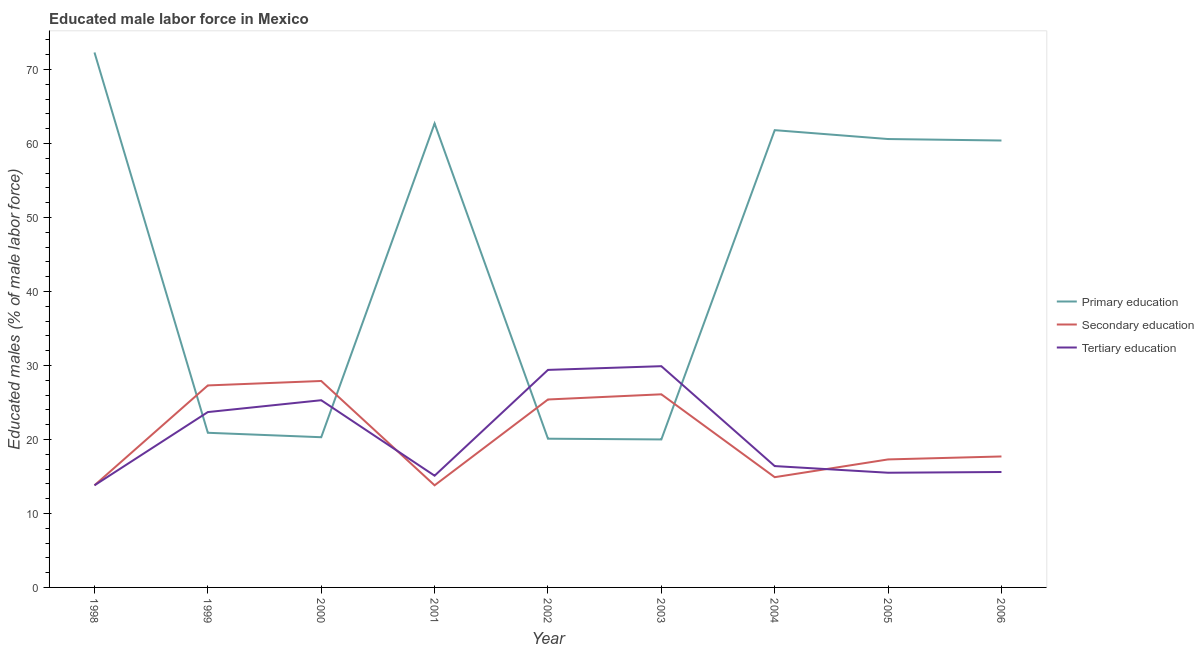How many different coloured lines are there?
Provide a short and direct response. 3. Does the line corresponding to percentage of male labor force who received secondary education intersect with the line corresponding to percentage of male labor force who received primary education?
Make the answer very short. Yes. What is the percentage of male labor force who received primary education in 1999?
Your answer should be compact. 20.9. Across all years, what is the maximum percentage of male labor force who received primary education?
Your answer should be very brief. 72.3. In which year was the percentage of male labor force who received tertiary education maximum?
Offer a very short reply. 2003. In which year was the percentage of male labor force who received primary education minimum?
Give a very brief answer. 2003. What is the total percentage of male labor force who received primary education in the graph?
Ensure brevity in your answer.  399.1. What is the difference between the percentage of male labor force who received secondary education in 1998 and that in 2004?
Your answer should be compact. -1.1. What is the difference between the percentage of male labor force who received primary education in 2004 and the percentage of male labor force who received secondary education in 2005?
Keep it short and to the point. 44.5. What is the average percentage of male labor force who received primary education per year?
Your response must be concise. 44.34. In the year 2003, what is the difference between the percentage of male labor force who received tertiary education and percentage of male labor force who received primary education?
Your answer should be very brief. 9.9. In how many years, is the percentage of male labor force who received secondary education greater than 18 %?
Keep it short and to the point. 4. What is the ratio of the percentage of male labor force who received secondary education in 2005 to that in 2006?
Give a very brief answer. 0.98. Is the percentage of male labor force who received tertiary education in 2003 less than that in 2004?
Offer a very short reply. No. Is the difference between the percentage of male labor force who received primary education in 1998 and 2006 greater than the difference between the percentage of male labor force who received secondary education in 1998 and 2006?
Your response must be concise. Yes. What is the difference between the highest and the lowest percentage of male labor force who received secondary education?
Ensure brevity in your answer.  14.1. Is the sum of the percentage of male labor force who received tertiary education in 2000 and 2004 greater than the maximum percentage of male labor force who received primary education across all years?
Make the answer very short. No. Is the percentage of male labor force who received secondary education strictly less than the percentage of male labor force who received primary education over the years?
Provide a short and direct response. No. How many lines are there?
Your response must be concise. 3. What is the difference between two consecutive major ticks on the Y-axis?
Keep it short and to the point. 10. Does the graph contain any zero values?
Offer a very short reply. No. Does the graph contain grids?
Offer a terse response. No. How many legend labels are there?
Ensure brevity in your answer.  3. What is the title of the graph?
Provide a succinct answer. Educated male labor force in Mexico. Does "Social Insurance" appear as one of the legend labels in the graph?
Your answer should be compact. No. What is the label or title of the Y-axis?
Offer a very short reply. Educated males (% of male labor force). What is the Educated males (% of male labor force) of Primary education in 1998?
Ensure brevity in your answer.  72.3. What is the Educated males (% of male labor force) of Secondary education in 1998?
Your answer should be very brief. 13.8. What is the Educated males (% of male labor force) of Tertiary education in 1998?
Your response must be concise. 13.8. What is the Educated males (% of male labor force) of Primary education in 1999?
Your answer should be very brief. 20.9. What is the Educated males (% of male labor force) in Secondary education in 1999?
Make the answer very short. 27.3. What is the Educated males (% of male labor force) of Tertiary education in 1999?
Give a very brief answer. 23.7. What is the Educated males (% of male labor force) of Primary education in 2000?
Your answer should be compact. 20.3. What is the Educated males (% of male labor force) of Secondary education in 2000?
Keep it short and to the point. 27.9. What is the Educated males (% of male labor force) in Tertiary education in 2000?
Keep it short and to the point. 25.3. What is the Educated males (% of male labor force) in Primary education in 2001?
Make the answer very short. 62.7. What is the Educated males (% of male labor force) in Secondary education in 2001?
Keep it short and to the point. 13.8. What is the Educated males (% of male labor force) of Tertiary education in 2001?
Make the answer very short. 15.1. What is the Educated males (% of male labor force) in Primary education in 2002?
Your answer should be compact. 20.1. What is the Educated males (% of male labor force) of Secondary education in 2002?
Make the answer very short. 25.4. What is the Educated males (% of male labor force) of Tertiary education in 2002?
Provide a short and direct response. 29.4. What is the Educated males (% of male labor force) of Primary education in 2003?
Provide a succinct answer. 20. What is the Educated males (% of male labor force) in Secondary education in 2003?
Give a very brief answer. 26.1. What is the Educated males (% of male labor force) in Tertiary education in 2003?
Offer a terse response. 29.9. What is the Educated males (% of male labor force) in Primary education in 2004?
Offer a terse response. 61.8. What is the Educated males (% of male labor force) in Secondary education in 2004?
Your answer should be compact. 14.9. What is the Educated males (% of male labor force) in Tertiary education in 2004?
Give a very brief answer. 16.4. What is the Educated males (% of male labor force) in Primary education in 2005?
Keep it short and to the point. 60.6. What is the Educated males (% of male labor force) of Secondary education in 2005?
Ensure brevity in your answer.  17.3. What is the Educated males (% of male labor force) of Primary education in 2006?
Offer a very short reply. 60.4. What is the Educated males (% of male labor force) of Secondary education in 2006?
Offer a terse response. 17.7. What is the Educated males (% of male labor force) in Tertiary education in 2006?
Offer a terse response. 15.6. Across all years, what is the maximum Educated males (% of male labor force) of Primary education?
Provide a short and direct response. 72.3. Across all years, what is the maximum Educated males (% of male labor force) in Secondary education?
Make the answer very short. 27.9. Across all years, what is the maximum Educated males (% of male labor force) in Tertiary education?
Offer a terse response. 29.9. Across all years, what is the minimum Educated males (% of male labor force) in Primary education?
Provide a succinct answer. 20. Across all years, what is the minimum Educated males (% of male labor force) in Secondary education?
Make the answer very short. 13.8. Across all years, what is the minimum Educated males (% of male labor force) of Tertiary education?
Keep it short and to the point. 13.8. What is the total Educated males (% of male labor force) in Primary education in the graph?
Your answer should be compact. 399.1. What is the total Educated males (% of male labor force) in Secondary education in the graph?
Provide a short and direct response. 184.2. What is the total Educated males (% of male labor force) of Tertiary education in the graph?
Your answer should be very brief. 184.7. What is the difference between the Educated males (% of male labor force) of Primary education in 1998 and that in 1999?
Offer a very short reply. 51.4. What is the difference between the Educated males (% of male labor force) in Secondary education in 1998 and that in 1999?
Provide a succinct answer. -13.5. What is the difference between the Educated males (% of male labor force) in Tertiary education in 1998 and that in 1999?
Keep it short and to the point. -9.9. What is the difference between the Educated males (% of male labor force) of Secondary education in 1998 and that in 2000?
Your response must be concise. -14.1. What is the difference between the Educated males (% of male labor force) in Tertiary education in 1998 and that in 2000?
Your answer should be compact. -11.5. What is the difference between the Educated males (% of male labor force) in Primary education in 1998 and that in 2002?
Provide a succinct answer. 52.2. What is the difference between the Educated males (% of male labor force) in Tertiary education in 1998 and that in 2002?
Your response must be concise. -15.6. What is the difference between the Educated males (% of male labor force) in Primary education in 1998 and that in 2003?
Offer a very short reply. 52.3. What is the difference between the Educated males (% of male labor force) of Tertiary education in 1998 and that in 2003?
Offer a very short reply. -16.1. What is the difference between the Educated males (% of male labor force) in Primary education in 1998 and that in 2004?
Make the answer very short. 10.5. What is the difference between the Educated males (% of male labor force) in Tertiary education in 1998 and that in 2004?
Your response must be concise. -2.6. What is the difference between the Educated males (% of male labor force) in Secondary education in 1998 and that in 2005?
Your answer should be very brief. -3.5. What is the difference between the Educated males (% of male labor force) in Tertiary education in 1998 and that in 2005?
Offer a very short reply. -1.7. What is the difference between the Educated males (% of male labor force) of Tertiary education in 1999 and that in 2000?
Your answer should be compact. -1.6. What is the difference between the Educated males (% of male labor force) of Primary education in 1999 and that in 2001?
Provide a succinct answer. -41.8. What is the difference between the Educated males (% of male labor force) of Secondary education in 1999 and that in 2001?
Offer a very short reply. 13.5. What is the difference between the Educated males (% of male labor force) in Secondary education in 1999 and that in 2002?
Provide a short and direct response. 1.9. What is the difference between the Educated males (% of male labor force) of Secondary education in 1999 and that in 2003?
Ensure brevity in your answer.  1.2. What is the difference between the Educated males (% of male labor force) of Primary education in 1999 and that in 2004?
Provide a succinct answer. -40.9. What is the difference between the Educated males (% of male labor force) of Secondary education in 1999 and that in 2004?
Keep it short and to the point. 12.4. What is the difference between the Educated males (% of male labor force) in Tertiary education in 1999 and that in 2004?
Give a very brief answer. 7.3. What is the difference between the Educated males (% of male labor force) in Primary education in 1999 and that in 2005?
Provide a short and direct response. -39.7. What is the difference between the Educated males (% of male labor force) of Secondary education in 1999 and that in 2005?
Keep it short and to the point. 10. What is the difference between the Educated males (% of male labor force) in Tertiary education in 1999 and that in 2005?
Ensure brevity in your answer.  8.2. What is the difference between the Educated males (% of male labor force) in Primary education in 1999 and that in 2006?
Give a very brief answer. -39.5. What is the difference between the Educated males (% of male labor force) of Secondary education in 1999 and that in 2006?
Your answer should be compact. 9.6. What is the difference between the Educated males (% of male labor force) of Primary education in 2000 and that in 2001?
Ensure brevity in your answer.  -42.4. What is the difference between the Educated males (% of male labor force) of Secondary education in 2000 and that in 2001?
Keep it short and to the point. 14.1. What is the difference between the Educated males (% of male labor force) in Secondary education in 2000 and that in 2002?
Your answer should be compact. 2.5. What is the difference between the Educated males (% of male labor force) in Secondary education in 2000 and that in 2003?
Offer a very short reply. 1.8. What is the difference between the Educated males (% of male labor force) of Tertiary education in 2000 and that in 2003?
Provide a short and direct response. -4.6. What is the difference between the Educated males (% of male labor force) of Primary education in 2000 and that in 2004?
Your response must be concise. -41.5. What is the difference between the Educated males (% of male labor force) in Secondary education in 2000 and that in 2004?
Keep it short and to the point. 13. What is the difference between the Educated males (% of male labor force) of Tertiary education in 2000 and that in 2004?
Your response must be concise. 8.9. What is the difference between the Educated males (% of male labor force) of Primary education in 2000 and that in 2005?
Offer a terse response. -40.3. What is the difference between the Educated males (% of male labor force) of Primary education in 2000 and that in 2006?
Give a very brief answer. -40.1. What is the difference between the Educated males (% of male labor force) in Secondary education in 2000 and that in 2006?
Your answer should be compact. 10.2. What is the difference between the Educated males (% of male labor force) of Primary education in 2001 and that in 2002?
Give a very brief answer. 42.6. What is the difference between the Educated males (% of male labor force) in Tertiary education in 2001 and that in 2002?
Give a very brief answer. -14.3. What is the difference between the Educated males (% of male labor force) of Primary education in 2001 and that in 2003?
Offer a terse response. 42.7. What is the difference between the Educated males (% of male labor force) of Secondary education in 2001 and that in 2003?
Your answer should be compact. -12.3. What is the difference between the Educated males (% of male labor force) of Tertiary education in 2001 and that in 2003?
Keep it short and to the point. -14.8. What is the difference between the Educated males (% of male labor force) in Tertiary education in 2001 and that in 2004?
Make the answer very short. -1.3. What is the difference between the Educated males (% of male labor force) in Primary education in 2001 and that in 2005?
Keep it short and to the point. 2.1. What is the difference between the Educated males (% of male labor force) in Primary education in 2001 and that in 2006?
Offer a very short reply. 2.3. What is the difference between the Educated males (% of male labor force) in Primary education in 2002 and that in 2003?
Keep it short and to the point. 0.1. What is the difference between the Educated males (% of male labor force) of Primary education in 2002 and that in 2004?
Provide a succinct answer. -41.7. What is the difference between the Educated males (% of male labor force) of Secondary education in 2002 and that in 2004?
Your response must be concise. 10.5. What is the difference between the Educated males (% of male labor force) in Primary education in 2002 and that in 2005?
Make the answer very short. -40.5. What is the difference between the Educated males (% of male labor force) of Secondary education in 2002 and that in 2005?
Provide a succinct answer. 8.1. What is the difference between the Educated males (% of male labor force) of Tertiary education in 2002 and that in 2005?
Offer a terse response. 13.9. What is the difference between the Educated males (% of male labor force) in Primary education in 2002 and that in 2006?
Keep it short and to the point. -40.3. What is the difference between the Educated males (% of male labor force) of Primary education in 2003 and that in 2004?
Your response must be concise. -41.8. What is the difference between the Educated males (% of male labor force) in Primary education in 2003 and that in 2005?
Give a very brief answer. -40.6. What is the difference between the Educated males (% of male labor force) of Secondary education in 2003 and that in 2005?
Your answer should be very brief. 8.8. What is the difference between the Educated males (% of male labor force) in Tertiary education in 2003 and that in 2005?
Keep it short and to the point. 14.4. What is the difference between the Educated males (% of male labor force) of Primary education in 2003 and that in 2006?
Ensure brevity in your answer.  -40.4. What is the difference between the Educated males (% of male labor force) in Secondary education in 2003 and that in 2006?
Provide a short and direct response. 8.4. What is the difference between the Educated males (% of male labor force) of Primary education in 2004 and that in 2005?
Keep it short and to the point. 1.2. What is the difference between the Educated males (% of male labor force) in Tertiary education in 2004 and that in 2006?
Your response must be concise. 0.8. What is the difference between the Educated males (% of male labor force) of Tertiary education in 2005 and that in 2006?
Keep it short and to the point. -0.1. What is the difference between the Educated males (% of male labor force) of Primary education in 1998 and the Educated males (% of male labor force) of Secondary education in 1999?
Your answer should be very brief. 45. What is the difference between the Educated males (% of male labor force) in Primary education in 1998 and the Educated males (% of male labor force) in Tertiary education in 1999?
Make the answer very short. 48.6. What is the difference between the Educated males (% of male labor force) of Primary education in 1998 and the Educated males (% of male labor force) of Secondary education in 2000?
Offer a very short reply. 44.4. What is the difference between the Educated males (% of male labor force) of Primary education in 1998 and the Educated males (% of male labor force) of Secondary education in 2001?
Offer a terse response. 58.5. What is the difference between the Educated males (% of male labor force) of Primary education in 1998 and the Educated males (% of male labor force) of Tertiary education in 2001?
Provide a short and direct response. 57.2. What is the difference between the Educated males (% of male labor force) of Secondary education in 1998 and the Educated males (% of male labor force) of Tertiary education in 2001?
Offer a very short reply. -1.3. What is the difference between the Educated males (% of male labor force) in Primary education in 1998 and the Educated males (% of male labor force) in Secondary education in 2002?
Your answer should be very brief. 46.9. What is the difference between the Educated males (% of male labor force) of Primary education in 1998 and the Educated males (% of male labor force) of Tertiary education in 2002?
Offer a very short reply. 42.9. What is the difference between the Educated males (% of male labor force) in Secondary education in 1998 and the Educated males (% of male labor force) in Tertiary education in 2002?
Offer a terse response. -15.6. What is the difference between the Educated males (% of male labor force) in Primary education in 1998 and the Educated males (% of male labor force) in Secondary education in 2003?
Your answer should be very brief. 46.2. What is the difference between the Educated males (% of male labor force) in Primary education in 1998 and the Educated males (% of male labor force) in Tertiary education in 2003?
Your response must be concise. 42.4. What is the difference between the Educated males (% of male labor force) in Secondary education in 1998 and the Educated males (% of male labor force) in Tertiary education in 2003?
Provide a succinct answer. -16.1. What is the difference between the Educated males (% of male labor force) of Primary education in 1998 and the Educated males (% of male labor force) of Secondary education in 2004?
Your response must be concise. 57.4. What is the difference between the Educated males (% of male labor force) in Primary education in 1998 and the Educated males (% of male labor force) in Tertiary education in 2004?
Offer a terse response. 55.9. What is the difference between the Educated males (% of male labor force) in Secondary education in 1998 and the Educated males (% of male labor force) in Tertiary education in 2004?
Make the answer very short. -2.6. What is the difference between the Educated males (% of male labor force) in Primary education in 1998 and the Educated males (% of male labor force) in Tertiary education in 2005?
Keep it short and to the point. 56.8. What is the difference between the Educated males (% of male labor force) of Primary education in 1998 and the Educated males (% of male labor force) of Secondary education in 2006?
Give a very brief answer. 54.6. What is the difference between the Educated males (% of male labor force) of Primary education in 1998 and the Educated males (% of male labor force) of Tertiary education in 2006?
Give a very brief answer. 56.7. What is the difference between the Educated males (% of male labor force) in Secondary education in 1998 and the Educated males (% of male labor force) in Tertiary education in 2006?
Provide a succinct answer. -1.8. What is the difference between the Educated males (% of male labor force) of Primary education in 1999 and the Educated males (% of male labor force) of Secondary education in 2000?
Your response must be concise. -7. What is the difference between the Educated males (% of male labor force) in Primary education in 1999 and the Educated males (% of male labor force) in Tertiary education in 2000?
Provide a succinct answer. -4.4. What is the difference between the Educated males (% of male labor force) of Secondary education in 1999 and the Educated males (% of male labor force) of Tertiary education in 2000?
Give a very brief answer. 2. What is the difference between the Educated males (% of male labor force) of Primary education in 1999 and the Educated males (% of male labor force) of Secondary education in 2001?
Ensure brevity in your answer.  7.1. What is the difference between the Educated males (% of male labor force) in Primary education in 1999 and the Educated males (% of male labor force) in Tertiary education in 2001?
Offer a terse response. 5.8. What is the difference between the Educated males (% of male labor force) in Secondary education in 1999 and the Educated males (% of male labor force) in Tertiary education in 2001?
Your answer should be compact. 12.2. What is the difference between the Educated males (% of male labor force) of Primary education in 1999 and the Educated males (% of male labor force) of Tertiary education in 2002?
Your answer should be very brief. -8.5. What is the difference between the Educated males (% of male labor force) of Primary education in 1999 and the Educated males (% of male labor force) of Secondary education in 2003?
Ensure brevity in your answer.  -5.2. What is the difference between the Educated males (% of male labor force) in Primary education in 1999 and the Educated males (% of male labor force) in Tertiary education in 2004?
Keep it short and to the point. 4.5. What is the difference between the Educated males (% of male labor force) of Primary education in 1999 and the Educated males (% of male labor force) of Secondary education in 2005?
Keep it short and to the point. 3.6. What is the difference between the Educated males (% of male labor force) of Secondary education in 1999 and the Educated males (% of male labor force) of Tertiary education in 2006?
Keep it short and to the point. 11.7. What is the difference between the Educated males (% of male labor force) of Primary education in 2000 and the Educated males (% of male labor force) of Secondary education in 2001?
Ensure brevity in your answer.  6.5. What is the difference between the Educated males (% of male labor force) in Secondary education in 2000 and the Educated males (% of male labor force) in Tertiary education in 2001?
Provide a short and direct response. 12.8. What is the difference between the Educated males (% of male labor force) in Primary education in 2000 and the Educated males (% of male labor force) in Secondary education in 2004?
Offer a terse response. 5.4. What is the difference between the Educated males (% of male labor force) in Secondary education in 2000 and the Educated males (% of male labor force) in Tertiary education in 2004?
Offer a very short reply. 11.5. What is the difference between the Educated males (% of male labor force) in Primary education in 2000 and the Educated males (% of male labor force) in Tertiary education in 2005?
Your response must be concise. 4.8. What is the difference between the Educated males (% of male labor force) in Secondary education in 2000 and the Educated males (% of male labor force) in Tertiary education in 2005?
Make the answer very short. 12.4. What is the difference between the Educated males (% of male labor force) in Primary education in 2000 and the Educated males (% of male labor force) in Secondary education in 2006?
Your answer should be very brief. 2.6. What is the difference between the Educated males (% of male labor force) of Primary education in 2000 and the Educated males (% of male labor force) of Tertiary education in 2006?
Ensure brevity in your answer.  4.7. What is the difference between the Educated males (% of male labor force) in Secondary education in 2000 and the Educated males (% of male labor force) in Tertiary education in 2006?
Provide a short and direct response. 12.3. What is the difference between the Educated males (% of male labor force) in Primary education in 2001 and the Educated males (% of male labor force) in Secondary education in 2002?
Ensure brevity in your answer.  37.3. What is the difference between the Educated males (% of male labor force) in Primary education in 2001 and the Educated males (% of male labor force) in Tertiary education in 2002?
Your answer should be very brief. 33.3. What is the difference between the Educated males (% of male labor force) of Secondary education in 2001 and the Educated males (% of male labor force) of Tertiary education in 2002?
Keep it short and to the point. -15.6. What is the difference between the Educated males (% of male labor force) in Primary education in 2001 and the Educated males (% of male labor force) in Secondary education in 2003?
Give a very brief answer. 36.6. What is the difference between the Educated males (% of male labor force) of Primary education in 2001 and the Educated males (% of male labor force) of Tertiary education in 2003?
Keep it short and to the point. 32.8. What is the difference between the Educated males (% of male labor force) in Secondary education in 2001 and the Educated males (% of male labor force) in Tertiary education in 2003?
Offer a terse response. -16.1. What is the difference between the Educated males (% of male labor force) of Primary education in 2001 and the Educated males (% of male labor force) of Secondary education in 2004?
Ensure brevity in your answer.  47.8. What is the difference between the Educated males (% of male labor force) in Primary education in 2001 and the Educated males (% of male labor force) in Tertiary education in 2004?
Your answer should be very brief. 46.3. What is the difference between the Educated males (% of male labor force) of Primary education in 2001 and the Educated males (% of male labor force) of Secondary education in 2005?
Provide a short and direct response. 45.4. What is the difference between the Educated males (% of male labor force) of Primary education in 2001 and the Educated males (% of male labor force) of Tertiary education in 2005?
Give a very brief answer. 47.2. What is the difference between the Educated males (% of male labor force) in Secondary education in 2001 and the Educated males (% of male labor force) in Tertiary education in 2005?
Offer a very short reply. -1.7. What is the difference between the Educated males (% of male labor force) in Primary education in 2001 and the Educated males (% of male labor force) in Tertiary education in 2006?
Offer a very short reply. 47.1. What is the difference between the Educated males (% of male labor force) in Primary education in 2002 and the Educated males (% of male labor force) in Tertiary education in 2004?
Ensure brevity in your answer.  3.7. What is the difference between the Educated males (% of male labor force) of Primary education in 2002 and the Educated males (% of male labor force) of Secondary education in 2006?
Provide a succinct answer. 2.4. What is the difference between the Educated males (% of male labor force) of Primary education in 2002 and the Educated males (% of male labor force) of Tertiary education in 2006?
Make the answer very short. 4.5. What is the difference between the Educated males (% of male labor force) in Primary education in 2003 and the Educated males (% of male labor force) in Tertiary education in 2004?
Give a very brief answer. 3.6. What is the difference between the Educated males (% of male labor force) in Primary education in 2003 and the Educated males (% of male labor force) in Secondary education in 2005?
Your answer should be very brief. 2.7. What is the difference between the Educated males (% of male labor force) of Primary education in 2003 and the Educated males (% of male labor force) of Secondary education in 2006?
Offer a terse response. 2.3. What is the difference between the Educated males (% of male labor force) of Primary education in 2004 and the Educated males (% of male labor force) of Secondary education in 2005?
Offer a terse response. 44.5. What is the difference between the Educated males (% of male labor force) of Primary education in 2004 and the Educated males (% of male labor force) of Tertiary education in 2005?
Offer a very short reply. 46.3. What is the difference between the Educated males (% of male labor force) of Primary education in 2004 and the Educated males (% of male labor force) of Secondary education in 2006?
Provide a short and direct response. 44.1. What is the difference between the Educated males (% of male labor force) of Primary education in 2004 and the Educated males (% of male labor force) of Tertiary education in 2006?
Make the answer very short. 46.2. What is the difference between the Educated males (% of male labor force) in Primary education in 2005 and the Educated males (% of male labor force) in Secondary education in 2006?
Offer a terse response. 42.9. What is the difference between the Educated males (% of male labor force) of Primary education in 2005 and the Educated males (% of male labor force) of Tertiary education in 2006?
Offer a terse response. 45. What is the average Educated males (% of male labor force) in Primary education per year?
Ensure brevity in your answer.  44.34. What is the average Educated males (% of male labor force) in Secondary education per year?
Your answer should be very brief. 20.47. What is the average Educated males (% of male labor force) in Tertiary education per year?
Provide a succinct answer. 20.52. In the year 1998, what is the difference between the Educated males (% of male labor force) in Primary education and Educated males (% of male labor force) in Secondary education?
Make the answer very short. 58.5. In the year 1998, what is the difference between the Educated males (% of male labor force) of Primary education and Educated males (% of male labor force) of Tertiary education?
Keep it short and to the point. 58.5. In the year 1999, what is the difference between the Educated males (% of male labor force) in Primary education and Educated males (% of male labor force) in Secondary education?
Provide a short and direct response. -6.4. In the year 1999, what is the difference between the Educated males (% of male labor force) in Primary education and Educated males (% of male labor force) in Tertiary education?
Offer a very short reply. -2.8. In the year 2000, what is the difference between the Educated males (% of male labor force) of Primary education and Educated males (% of male labor force) of Secondary education?
Provide a succinct answer. -7.6. In the year 2001, what is the difference between the Educated males (% of male labor force) of Primary education and Educated males (% of male labor force) of Secondary education?
Offer a terse response. 48.9. In the year 2001, what is the difference between the Educated males (% of male labor force) in Primary education and Educated males (% of male labor force) in Tertiary education?
Keep it short and to the point. 47.6. In the year 2003, what is the difference between the Educated males (% of male labor force) in Secondary education and Educated males (% of male labor force) in Tertiary education?
Provide a succinct answer. -3.8. In the year 2004, what is the difference between the Educated males (% of male labor force) of Primary education and Educated males (% of male labor force) of Secondary education?
Give a very brief answer. 46.9. In the year 2004, what is the difference between the Educated males (% of male labor force) of Primary education and Educated males (% of male labor force) of Tertiary education?
Give a very brief answer. 45.4. In the year 2004, what is the difference between the Educated males (% of male labor force) in Secondary education and Educated males (% of male labor force) in Tertiary education?
Provide a short and direct response. -1.5. In the year 2005, what is the difference between the Educated males (% of male labor force) of Primary education and Educated males (% of male labor force) of Secondary education?
Offer a very short reply. 43.3. In the year 2005, what is the difference between the Educated males (% of male labor force) of Primary education and Educated males (% of male labor force) of Tertiary education?
Your answer should be compact. 45.1. In the year 2005, what is the difference between the Educated males (% of male labor force) in Secondary education and Educated males (% of male labor force) in Tertiary education?
Your answer should be compact. 1.8. In the year 2006, what is the difference between the Educated males (% of male labor force) of Primary education and Educated males (% of male labor force) of Secondary education?
Give a very brief answer. 42.7. In the year 2006, what is the difference between the Educated males (% of male labor force) of Primary education and Educated males (% of male labor force) of Tertiary education?
Your response must be concise. 44.8. In the year 2006, what is the difference between the Educated males (% of male labor force) in Secondary education and Educated males (% of male labor force) in Tertiary education?
Offer a very short reply. 2.1. What is the ratio of the Educated males (% of male labor force) of Primary education in 1998 to that in 1999?
Make the answer very short. 3.46. What is the ratio of the Educated males (% of male labor force) of Secondary education in 1998 to that in 1999?
Keep it short and to the point. 0.51. What is the ratio of the Educated males (% of male labor force) of Tertiary education in 1998 to that in 1999?
Keep it short and to the point. 0.58. What is the ratio of the Educated males (% of male labor force) of Primary education in 1998 to that in 2000?
Your answer should be very brief. 3.56. What is the ratio of the Educated males (% of male labor force) of Secondary education in 1998 to that in 2000?
Ensure brevity in your answer.  0.49. What is the ratio of the Educated males (% of male labor force) in Tertiary education in 1998 to that in 2000?
Your answer should be very brief. 0.55. What is the ratio of the Educated males (% of male labor force) in Primary education in 1998 to that in 2001?
Provide a short and direct response. 1.15. What is the ratio of the Educated males (% of male labor force) in Tertiary education in 1998 to that in 2001?
Provide a short and direct response. 0.91. What is the ratio of the Educated males (% of male labor force) in Primary education in 1998 to that in 2002?
Give a very brief answer. 3.6. What is the ratio of the Educated males (% of male labor force) of Secondary education in 1998 to that in 2002?
Offer a very short reply. 0.54. What is the ratio of the Educated males (% of male labor force) of Tertiary education in 1998 to that in 2002?
Offer a very short reply. 0.47. What is the ratio of the Educated males (% of male labor force) in Primary education in 1998 to that in 2003?
Offer a very short reply. 3.62. What is the ratio of the Educated males (% of male labor force) in Secondary education in 1998 to that in 2003?
Your response must be concise. 0.53. What is the ratio of the Educated males (% of male labor force) of Tertiary education in 1998 to that in 2003?
Your answer should be very brief. 0.46. What is the ratio of the Educated males (% of male labor force) in Primary education in 1998 to that in 2004?
Provide a succinct answer. 1.17. What is the ratio of the Educated males (% of male labor force) of Secondary education in 1998 to that in 2004?
Make the answer very short. 0.93. What is the ratio of the Educated males (% of male labor force) in Tertiary education in 1998 to that in 2004?
Your answer should be compact. 0.84. What is the ratio of the Educated males (% of male labor force) in Primary education in 1998 to that in 2005?
Your response must be concise. 1.19. What is the ratio of the Educated males (% of male labor force) of Secondary education in 1998 to that in 2005?
Make the answer very short. 0.8. What is the ratio of the Educated males (% of male labor force) of Tertiary education in 1998 to that in 2005?
Your response must be concise. 0.89. What is the ratio of the Educated males (% of male labor force) of Primary education in 1998 to that in 2006?
Your answer should be compact. 1.2. What is the ratio of the Educated males (% of male labor force) of Secondary education in 1998 to that in 2006?
Keep it short and to the point. 0.78. What is the ratio of the Educated males (% of male labor force) in Tertiary education in 1998 to that in 2006?
Give a very brief answer. 0.88. What is the ratio of the Educated males (% of male labor force) in Primary education in 1999 to that in 2000?
Provide a succinct answer. 1.03. What is the ratio of the Educated males (% of male labor force) of Secondary education in 1999 to that in 2000?
Provide a short and direct response. 0.98. What is the ratio of the Educated males (% of male labor force) in Tertiary education in 1999 to that in 2000?
Your response must be concise. 0.94. What is the ratio of the Educated males (% of male labor force) of Secondary education in 1999 to that in 2001?
Offer a very short reply. 1.98. What is the ratio of the Educated males (% of male labor force) of Tertiary education in 1999 to that in 2001?
Make the answer very short. 1.57. What is the ratio of the Educated males (% of male labor force) in Primary education in 1999 to that in 2002?
Offer a terse response. 1.04. What is the ratio of the Educated males (% of male labor force) in Secondary education in 1999 to that in 2002?
Make the answer very short. 1.07. What is the ratio of the Educated males (% of male labor force) in Tertiary education in 1999 to that in 2002?
Your response must be concise. 0.81. What is the ratio of the Educated males (% of male labor force) in Primary education in 1999 to that in 2003?
Keep it short and to the point. 1.04. What is the ratio of the Educated males (% of male labor force) in Secondary education in 1999 to that in 2003?
Make the answer very short. 1.05. What is the ratio of the Educated males (% of male labor force) in Tertiary education in 1999 to that in 2003?
Give a very brief answer. 0.79. What is the ratio of the Educated males (% of male labor force) in Primary education in 1999 to that in 2004?
Your response must be concise. 0.34. What is the ratio of the Educated males (% of male labor force) in Secondary education in 1999 to that in 2004?
Ensure brevity in your answer.  1.83. What is the ratio of the Educated males (% of male labor force) of Tertiary education in 1999 to that in 2004?
Give a very brief answer. 1.45. What is the ratio of the Educated males (% of male labor force) in Primary education in 1999 to that in 2005?
Offer a terse response. 0.34. What is the ratio of the Educated males (% of male labor force) in Secondary education in 1999 to that in 2005?
Keep it short and to the point. 1.58. What is the ratio of the Educated males (% of male labor force) in Tertiary education in 1999 to that in 2005?
Give a very brief answer. 1.53. What is the ratio of the Educated males (% of male labor force) in Primary education in 1999 to that in 2006?
Give a very brief answer. 0.35. What is the ratio of the Educated males (% of male labor force) in Secondary education in 1999 to that in 2006?
Ensure brevity in your answer.  1.54. What is the ratio of the Educated males (% of male labor force) of Tertiary education in 1999 to that in 2006?
Offer a terse response. 1.52. What is the ratio of the Educated males (% of male labor force) in Primary education in 2000 to that in 2001?
Your response must be concise. 0.32. What is the ratio of the Educated males (% of male labor force) in Secondary education in 2000 to that in 2001?
Give a very brief answer. 2.02. What is the ratio of the Educated males (% of male labor force) of Tertiary education in 2000 to that in 2001?
Keep it short and to the point. 1.68. What is the ratio of the Educated males (% of male labor force) in Secondary education in 2000 to that in 2002?
Provide a short and direct response. 1.1. What is the ratio of the Educated males (% of male labor force) of Tertiary education in 2000 to that in 2002?
Provide a short and direct response. 0.86. What is the ratio of the Educated males (% of male labor force) of Secondary education in 2000 to that in 2003?
Provide a succinct answer. 1.07. What is the ratio of the Educated males (% of male labor force) in Tertiary education in 2000 to that in 2003?
Offer a terse response. 0.85. What is the ratio of the Educated males (% of male labor force) of Primary education in 2000 to that in 2004?
Keep it short and to the point. 0.33. What is the ratio of the Educated males (% of male labor force) in Secondary education in 2000 to that in 2004?
Provide a succinct answer. 1.87. What is the ratio of the Educated males (% of male labor force) of Tertiary education in 2000 to that in 2004?
Your answer should be compact. 1.54. What is the ratio of the Educated males (% of male labor force) of Primary education in 2000 to that in 2005?
Your answer should be very brief. 0.34. What is the ratio of the Educated males (% of male labor force) of Secondary education in 2000 to that in 2005?
Make the answer very short. 1.61. What is the ratio of the Educated males (% of male labor force) of Tertiary education in 2000 to that in 2005?
Your answer should be compact. 1.63. What is the ratio of the Educated males (% of male labor force) in Primary education in 2000 to that in 2006?
Offer a terse response. 0.34. What is the ratio of the Educated males (% of male labor force) in Secondary education in 2000 to that in 2006?
Offer a very short reply. 1.58. What is the ratio of the Educated males (% of male labor force) of Tertiary education in 2000 to that in 2006?
Your answer should be very brief. 1.62. What is the ratio of the Educated males (% of male labor force) in Primary education in 2001 to that in 2002?
Give a very brief answer. 3.12. What is the ratio of the Educated males (% of male labor force) in Secondary education in 2001 to that in 2002?
Ensure brevity in your answer.  0.54. What is the ratio of the Educated males (% of male labor force) of Tertiary education in 2001 to that in 2002?
Keep it short and to the point. 0.51. What is the ratio of the Educated males (% of male labor force) of Primary education in 2001 to that in 2003?
Make the answer very short. 3.13. What is the ratio of the Educated males (% of male labor force) in Secondary education in 2001 to that in 2003?
Keep it short and to the point. 0.53. What is the ratio of the Educated males (% of male labor force) in Tertiary education in 2001 to that in 2003?
Keep it short and to the point. 0.51. What is the ratio of the Educated males (% of male labor force) in Primary education in 2001 to that in 2004?
Offer a very short reply. 1.01. What is the ratio of the Educated males (% of male labor force) of Secondary education in 2001 to that in 2004?
Make the answer very short. 0.93. What is the ratio of the Educated males (% of male labor force) in Tertiary education in 2001 to that in 2004?
Your answer should be very brief. 0.92. What is the ratio of the Educated males (% of male labor force) of Primary education in 2001 to that in 2005?
Offer a terse response. 1.03. What is the ratio of the Educated males (% of male labor force) in Secondary education in 2001 to that in 2005?
Offer a very short reply. 0.8. What is the ratio of the Educated males (% of male labor force) of Tertiary education in 2001 to that in 2005?
Give a very brief answer. 0.97. What is the ratio of the Educated males (% of male labor force) in Primary education in 2001 to that in 2006?
Provide a succinct answer. 1.04. What is the ratio of the Educated males (% of male labor force) of Secondary education in 2001 to that in 2006?
Offer a very short reply. 0.78. What is the ratio of the Educated males (% of male labor force) of Tertiary education in 2001 to that in 2006?
Make the answer very short. 0.97. What is the ratio of the Educated males (% of male labor force) in Primary education in 2002 to that in 2003?
Make the answer very short. 1. What is the ratio of the Educated males (% of male labor force) of Secondary education in 2002 to that in 2003?
Your answer should be very brief. 0.97. What is the ratio of the Educated males (% of male labor force) in Tertiary education in 2002 to that in 2003?
Keep it short and to the point. 0.98. What is the ratio of the Educated males (% of male labor force) in Primary education in 2002 to that in 2004?
Your answer should be compact. 0.33. What is the ratio of the Educated males (% of male labor force) of Secondary education in 2002 to that in 2004?
Your response must be concise. 1.7. What is the ratio of the Educated males (% of male labor force) in Tertiary education in 2002 to that in 2004?
Provide a short and direct response. 1.79. What is the ratio of the Educated males (% of male labor force) in Primary education in 2002 to that in 2005?
Give a very brief answer. 0.33. What is the ratio of the Educated males (% of male labor force) of Secondary education in 2002 to that in 2005?
Ensure brevity in your answer.  1.47. What is the ratio of the Educated males (% of male labor force) of Tertiary education in 2002 to that in 2005?
Offer a terse response. 1.9. What is the ratio of the Educated males (% of male labor force) of Primary education in 2002 to that in 2006?
Your answer should be very brief. 0.33. What is the ratio of the Educated males (% of male labor force) of Secondary education in 2002 to that in 2006?
Ensure brevity in your answer.  1.44. What is the ratio of the Educated males (% of male labor force) of Tertiary education in 2002 to that in 2006?
Offer a very short reply. 1.88. What is the ratio of the Educated males (% of male labor force) in Primary education in 2003 to that in 2004?
Keep it short and to the point. 0.32. What is the ratio of the Educated males (% of male labor force) in Secondary education in 2003 to that in 2004?
Offer a very short reply. 1.75. What is the ratio of the Educated males (% of male labor force) of Tertiary education in 2003 to that in 2004?
Provide a succinct answer. 1.82. What is the ratio of the Educated males (% of male labor force) of Primary education in 2003 to that in 2005?
Your answer should be compact. 0.33. What is the ratio of the Educated males (% of male labor force) of Secondary education in 2003 to that in 2005?
Offer a terse response. 1.51. What is the ratio of the Educated males (% of male labor force) in Tertiary education in 2003 to that in 2005?
Give a very brief answer. 1.93. What is the ratio of the Educated males (% of male labor force) in Primary education in 2003 to that in 2006?
Keep it short and to the point. 0.33. What is the ratio of the Educated males (% of male labor force) in Secondary education in 2003 to that in 2006?
Your response must be concise. 1.47. What is the ratio of the Educated males (% of male labor force) in Tertiary education in 2003 to that in 2006?
Provide a succinct answer. 1.92. What is the ratio of the Educated males (% of male labor force) in Primary education in 2004 to that in 2005?
Provide a succinct answer. 1.02. What is the ratio of the Educated males (% of male labor force) in Secondary education in 2004 to that in 2005?
Your answer should be compact. 0.86. What is the ratio of the Educated males (% of male labor force) of Tertiary education in 2004 to that in 2005?
Offer a very short reply. 1.06. What is the ratio of the Educated males (% of male labor force) of Primary education in 2004 to that in 2006?
Your answer should be very brief. 1.02. What is the ratio of the Educated males (% of male labor force) of Secondary education in 2004 to that in 2006?
Keep it short and to the point. 0.84. What is the ratio of the Educated males (% of male labor force) of Tertiary education in 2004 to that in 2006?
Your response must be concise. 1.05. What is the ratio of the Educated males (% of male labor force) of Secondary education in 2005 to that in 2006?
Your response must be concise. 0.98. What is the ratio of the Educated males (% of male labor force) in Tertiary education in 2005 to that in 2006?
Offer a very short reply. 0.99. What is the difference between the highest and the lowest Educated males (% of male labor force) in Primary education?
Give a very brief answer. 52.3. What is the difference between the highest and the lowest Educated males (% of male labor force) of Secondary education?
Provide a succinct answer. 14.1. What is the difference between the highest and the lowest Educated males (% of male labor force) in Tertiary education?
Your response must be concise. 16.1. 